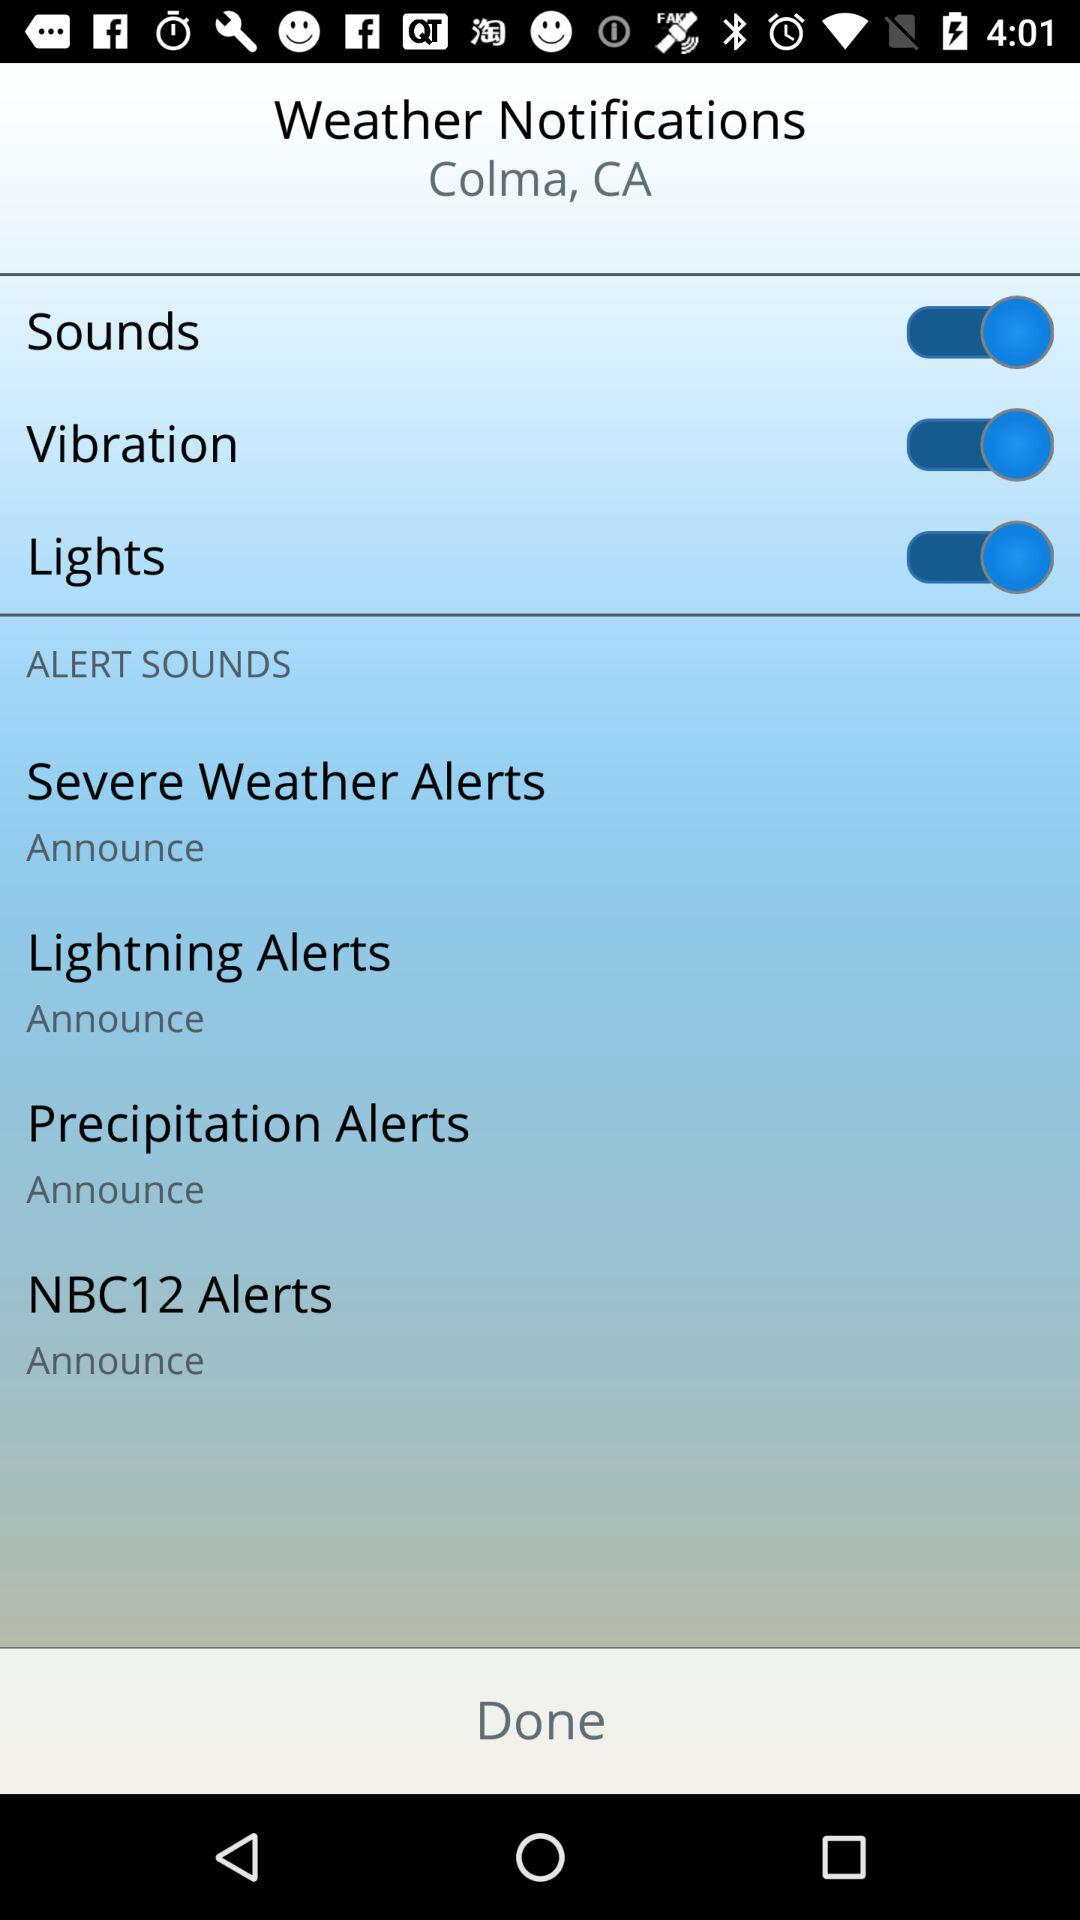How many alerts have a sound option?
Answer the question using a single word or phrase. 4 